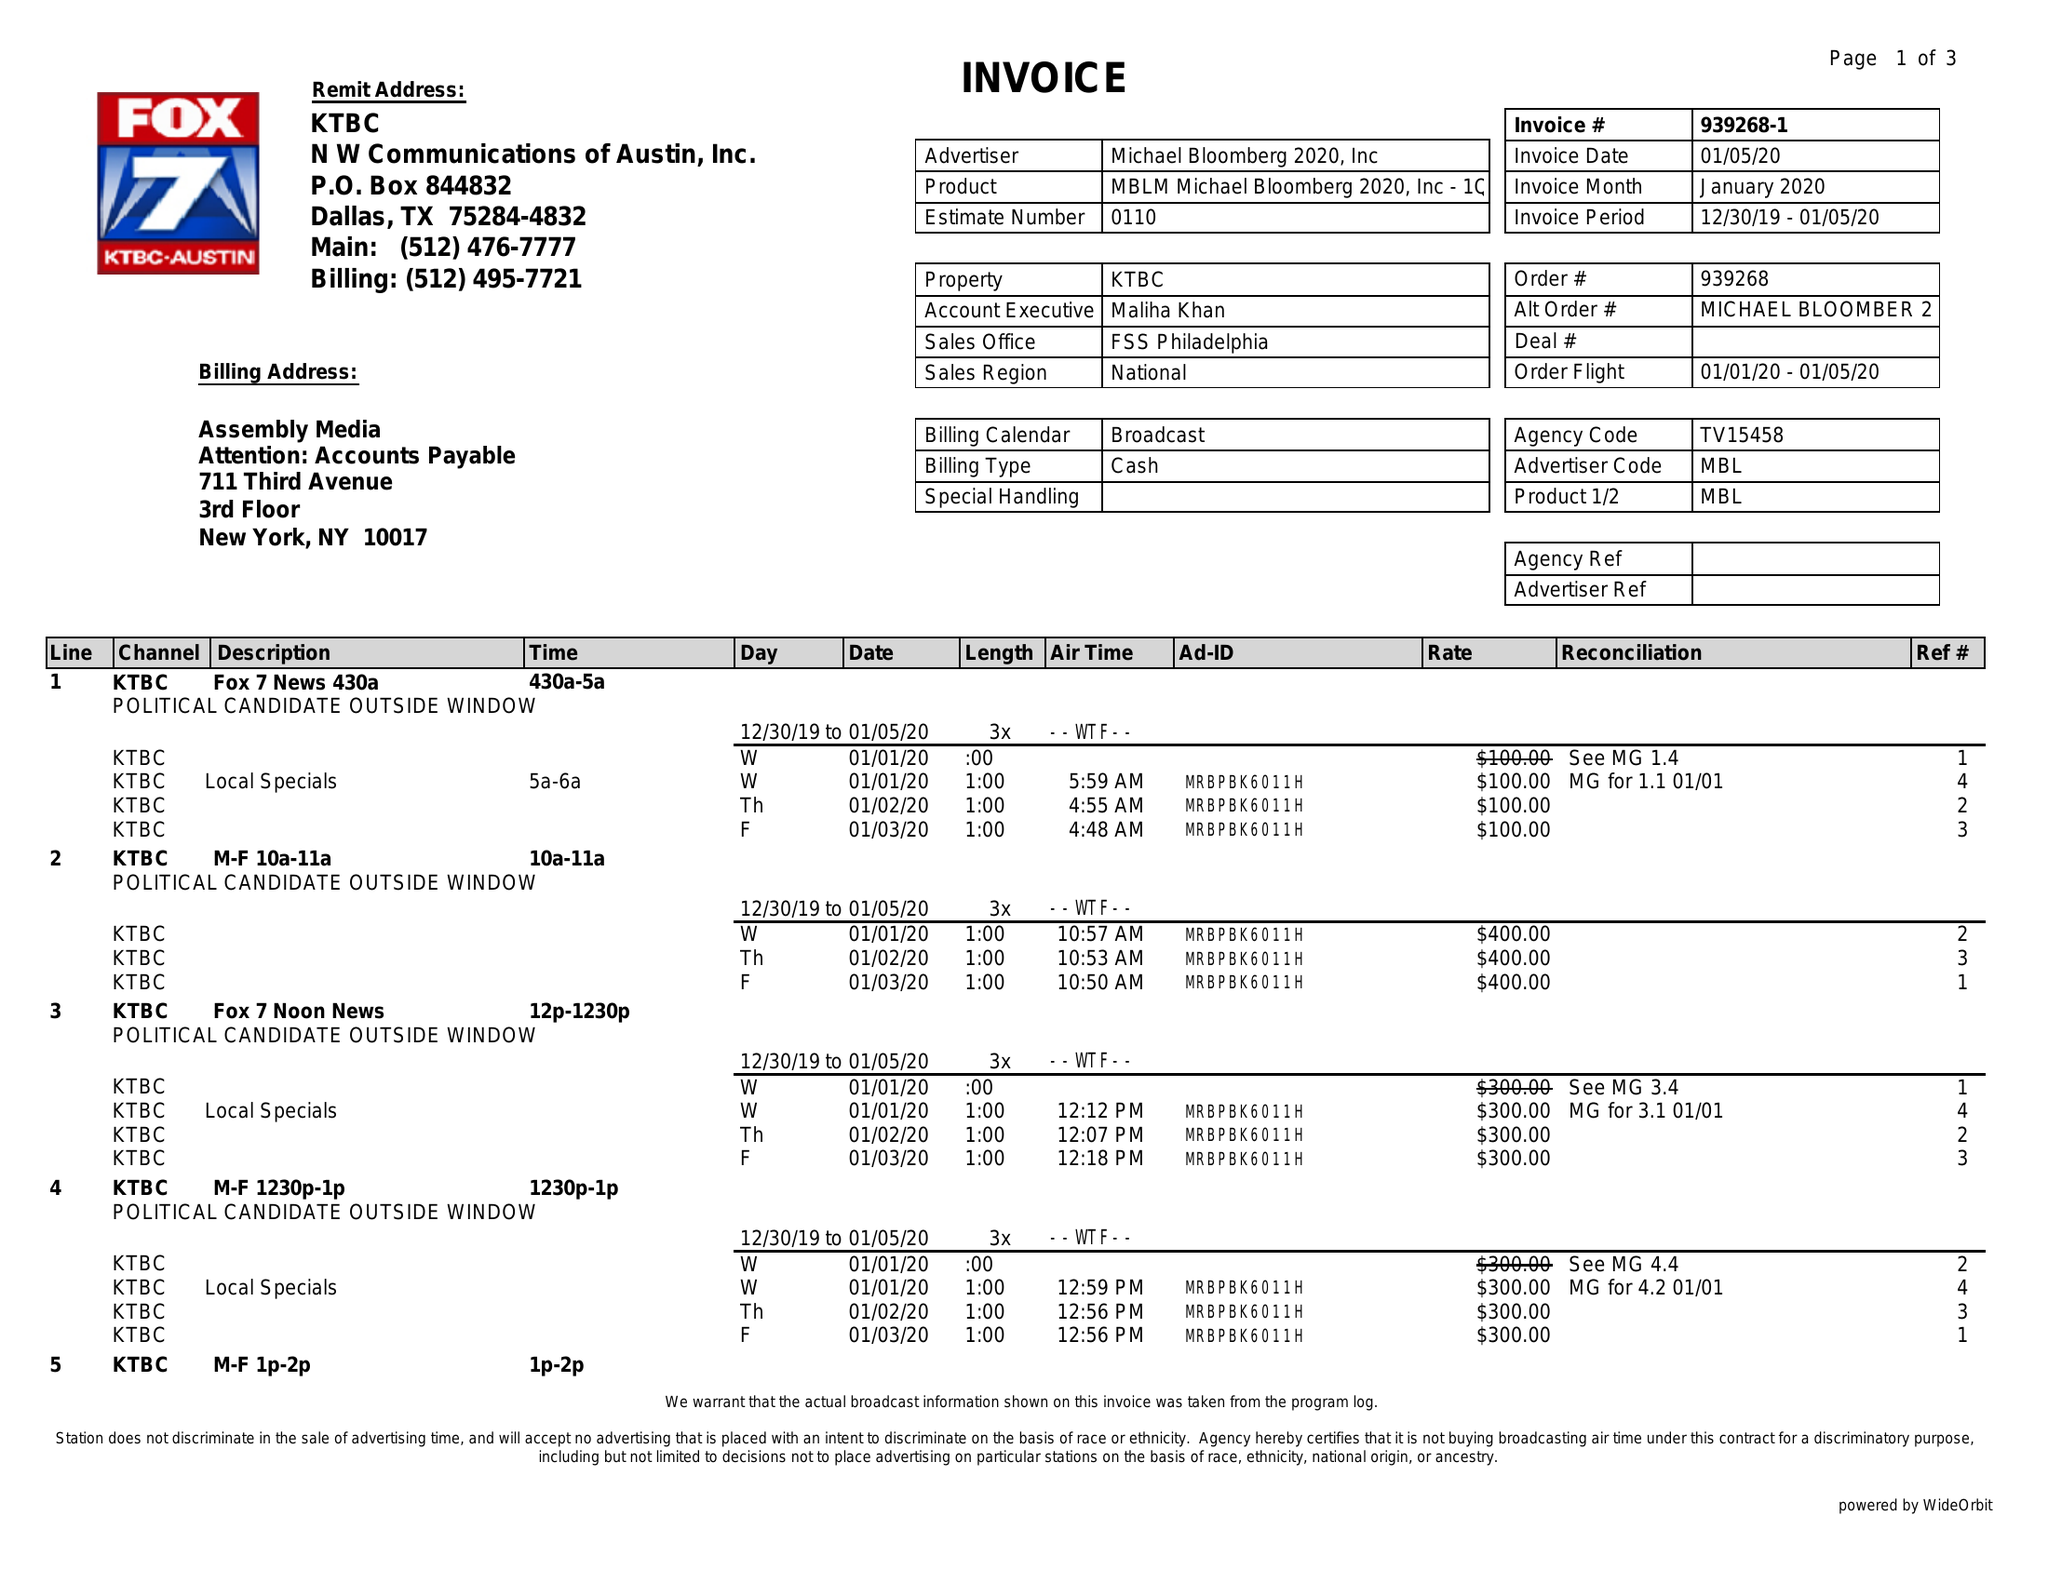What is the value for the contract_num?
Answer the question using a single word or phrase. 939268 